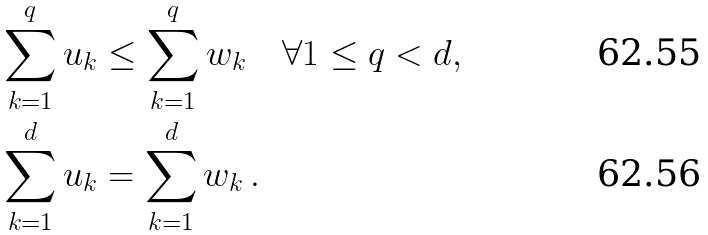<formula> <loc_0><loc_0><loc_500><loc_500>\sum _ { k = 1 } ^ { q } u _ { k } & \leq \sum _ { k = 1 } ^ { q } w _ { k } \quad \forall 1 \leq q < d , \\ \sum _ { k = 1 } ^ { d } u _ { k } & = \sum _ { k = 1 } ^ { d } w _ { k } \, .</formula> 